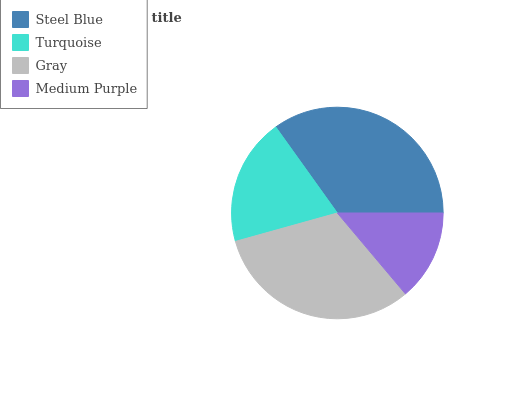Is Medium Purple the minimum?
Answer yes or no. Yes. Is Steel Blue the maximum?
Answer yes or no. Yes. Is Turquoise the minimum?
Answer yes or no. No. Is Turquoise the maximum?
Answer yes or no. No. Is Steel Blue greater than Turquoise?
Answer yes or no. Yes. Is Turquoise less than Steel Blue?
Answer yes or no. Yes. Is Turquoise greater than Steel Blue?
Answer yes or no. No. Is Steel Blue less than Turquoise?
Answer yes or no. No. Is Gray the high median?
Answer yes or no. Yes. Is Turquoise the low median?
Answer yes or no. Yes. Is Medium Purple the high median?
Answer yes or no. No. Is Medium Purple the low median?
Answer yes or no. No. 